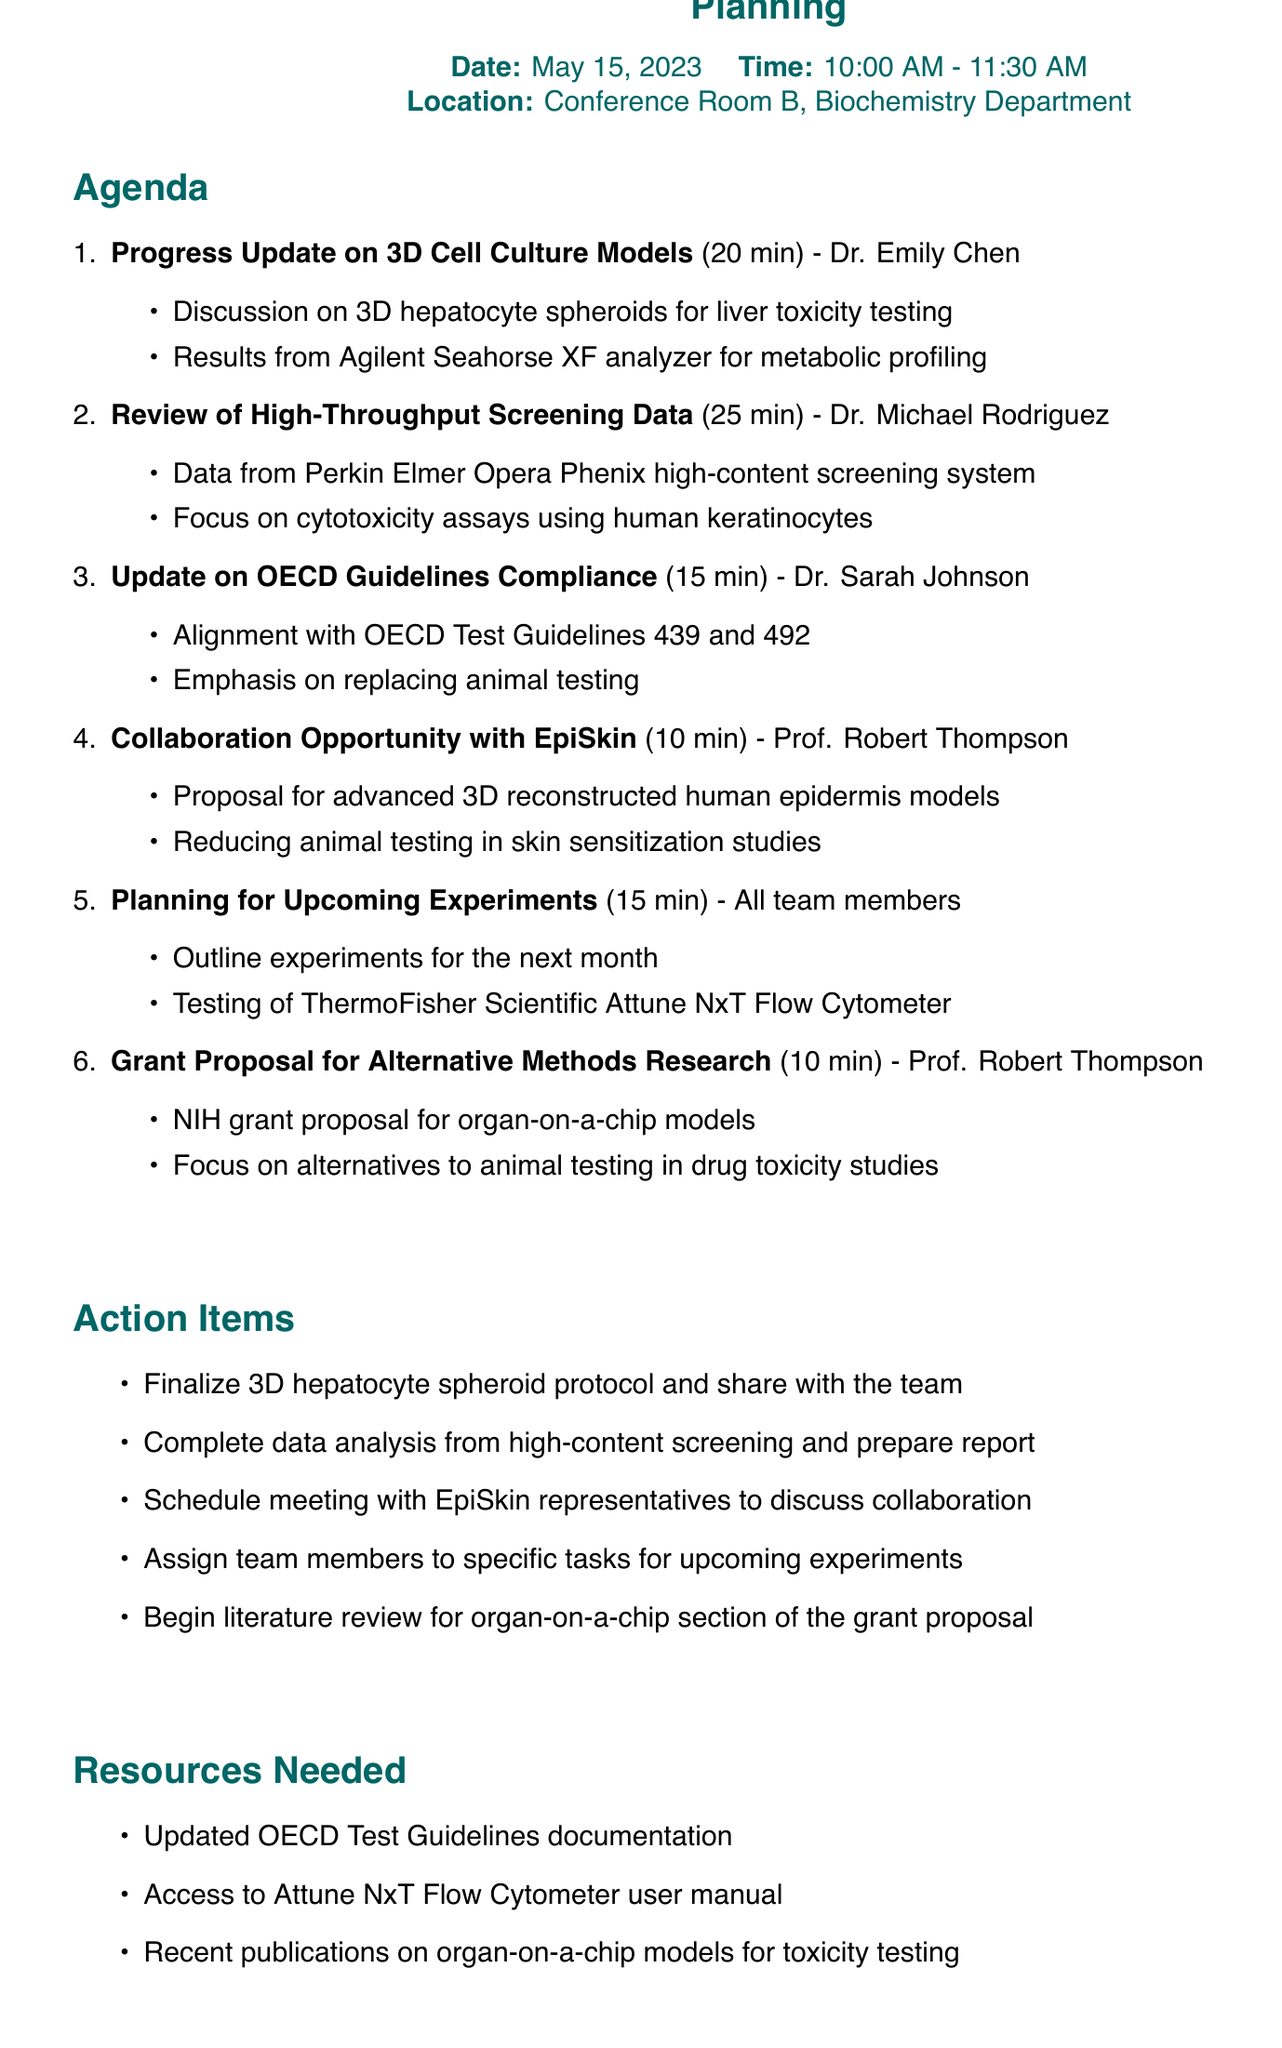What is the title of the meeting? The title is specified at the beginning of the document, which summarizes the focus of the lab meeting.
Answer: Weekly Lab Meeting: In Vitro Toxicity Assays Progress and Experiment Planning Who is presenting the progress update on 3D cell culture models? The presenter's name is mentioned next to the corresponding agenda item for a progress update.
Answer: Dr. Emily Chen What time does the meeting start? The starting time of the meeting is listed alongside other details in the document.
Answer: 10:00 AM How long is the presentation on high-throughput screening data? The duration for this agenda item is included next to the title of the presentation.
Answer: 25 minutes What is one of the action items listed in the document? The action items are outlined towards the end of the document in a separate section.
Answer: Finalize 3D hepatocyte spheroid protocol and share with the team Which OECD Test Guidelines are mentioned for compliance? The specific guidelines mentioned are listed under the update on compliance with OECD guidelines.
Answer: 439 and 492 What collaboration opportunity is proposed? The document outlines a specific proposal under the relevant agenda item for collaboration.
Answer: Collaborate with EpiSkin How many minutes are allocated for planning upcoming experiments? The duration for this agenda item is noted next to the title in the agenda.
Answer: 15 minutes 